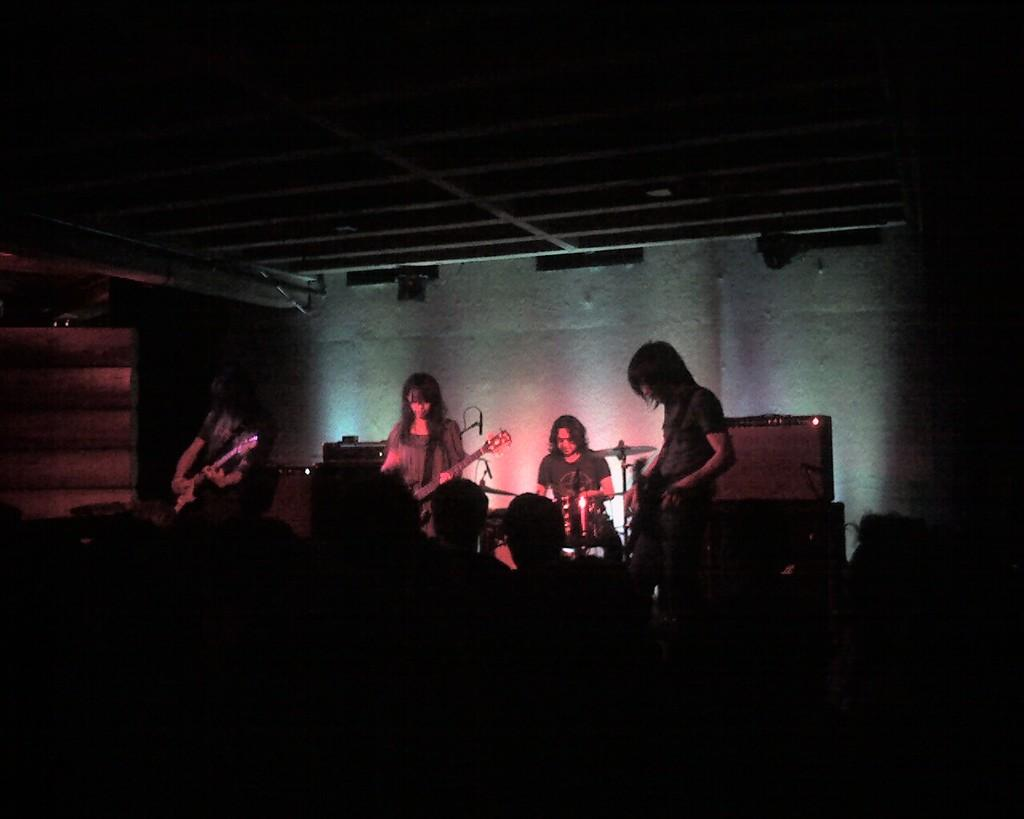What are the people in the image doing? The people in the image are playing musical instruments. How many people are playing musical instruments in the image? The number of people playing musical instruments cannot be determined from the provided facts. What else can be seen in the image besides the people playing instruments? There are lights visible in the image. What type of gun can be seen in the hands of the people playing musical instruments? There is no gun present in the image; the people are playing musical instruments. 